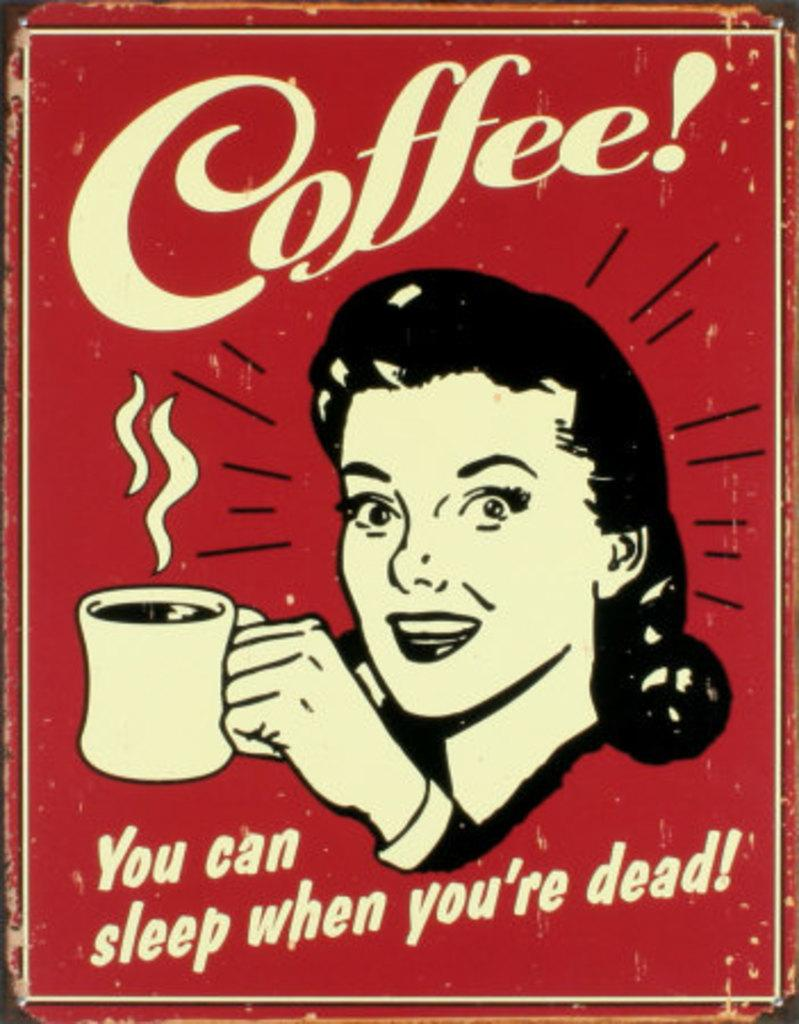What is the color of the poster in the image? The poster in the image is red. What image is depicted on the red poster? There is a picture of a woman holding a cup on the poster. What else is featured on the poster besides the image? There is text on the poster. What type of noise can be heard coming from the thing on the right side of the image? There is no thing or noise present in the image; it only features a red poster with a picture of a woman holding a cup and text. 